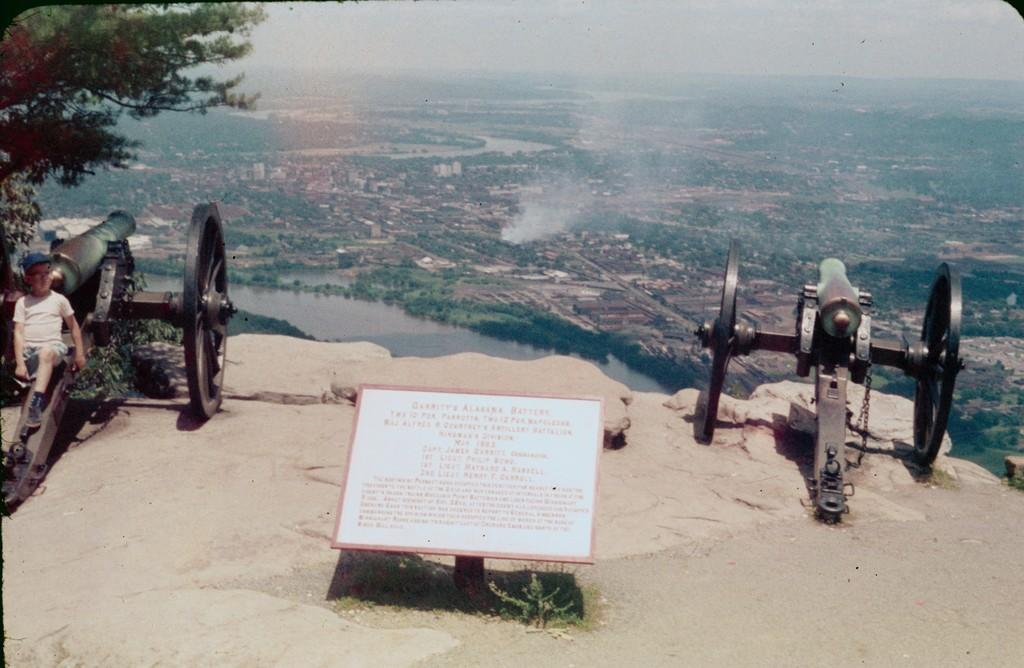What type of objects are present in the image? There are two war equipment in the image. What is the kid doing in the image? A kid is sitting on one of the equipment. What can be seen on the left side of the image? There is a tree on the left side of the image. What is visible in the background of the image? There is a river and a city beside the river in the background of the image. What is the condition of the recess in the image? There is no recess present in the image. How does the kid shake the war equipment in the image? The image does not show the kid shaking the war equipment; the kid is sitting on one of the equipment. 